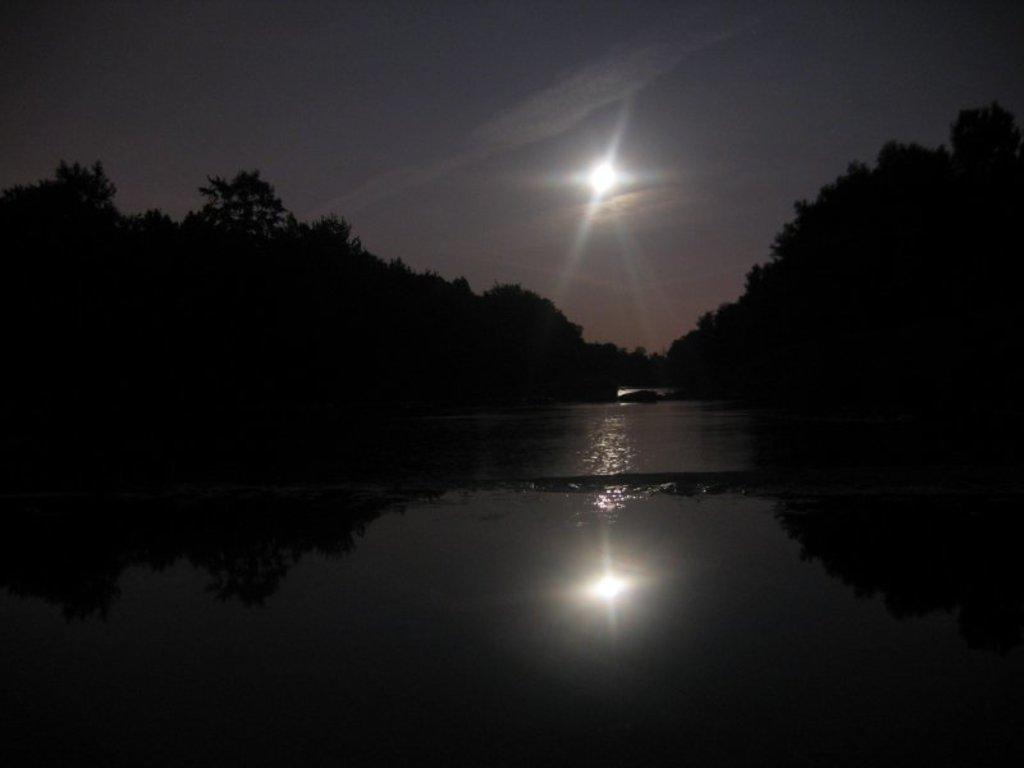Please provide a concise description of this image. This picture shows moon in the sky and we see trees on the both sides and water. 